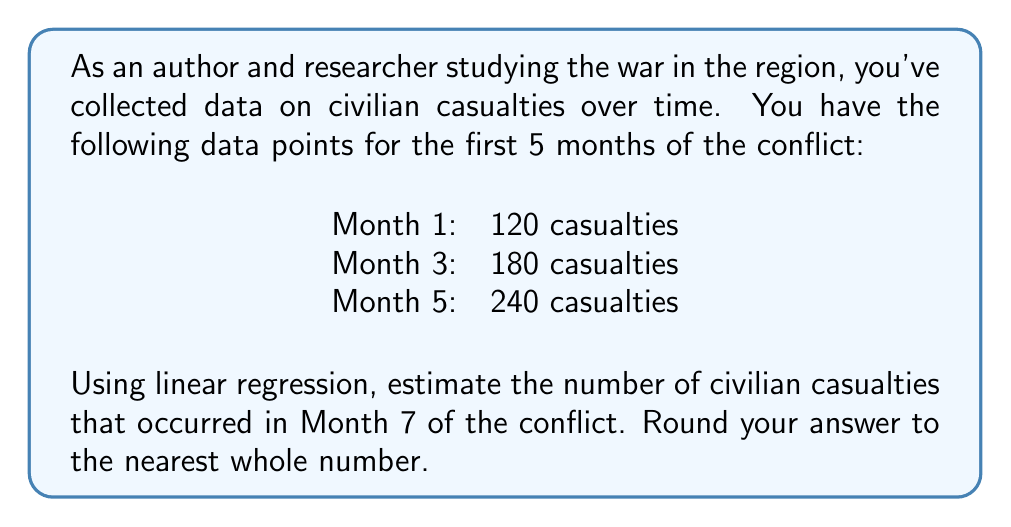Teach me how to tackle this problem. To solve this problem, we'll use linear regression to find the line of best fit and then use it to estimate the casualties for Month 7.

1. Let's define our variables:
   $x$ = month number
   $y$ = number of casualties

2. We have three data points: (1, 120), (3, 180), and (5, 240)

3. To find the slope (m) and y-intercept (b) of the line $y = mx + b$, we'll use these formulas:

   $$m = \frac{n\sum xy - \sum x \sum y}{n\sum x^2 - (\sum x)^2}$$

   $$b = \frac{\sum y - m\sum x}{n}$$

   where $n$ is the number of data points.

4. Calculate the necessary sums:
   $n = 3$
   $\sum x = 1 + 3 + 5 = 9$
   $\sum y = 120 + 180 + 240 = 540$
   $\sum xy = 1(120) + 3(180) + 5(240) = 1740$
   $\sum x^2 = 1^2 + 3^2 + 5^2 = 35$

5. Calculate the slope (m):
   $$m = \frac{3(1740) - 9(540)}{3(35) - 9^2} = \frac{5220 - 4860}{105 - 81} = \frac{360}{24} = 15$$

6. Calculate the y-intercept (b):
   $$b = \frac{540 - 15(9)}{3} = \frac{540 - 135}{3} = 135$$

7. Our linear regression equation is:
   $$y = 15x + 135$$

8. To estimate casualties for Month 7, substitute $x = 7$:
   $$y = 15(7) + 135 = 105 + 135 = 240$$

Therefore, the estimated number of civilian casualties for Month 7 is 240.
Answer: 240 casualties 